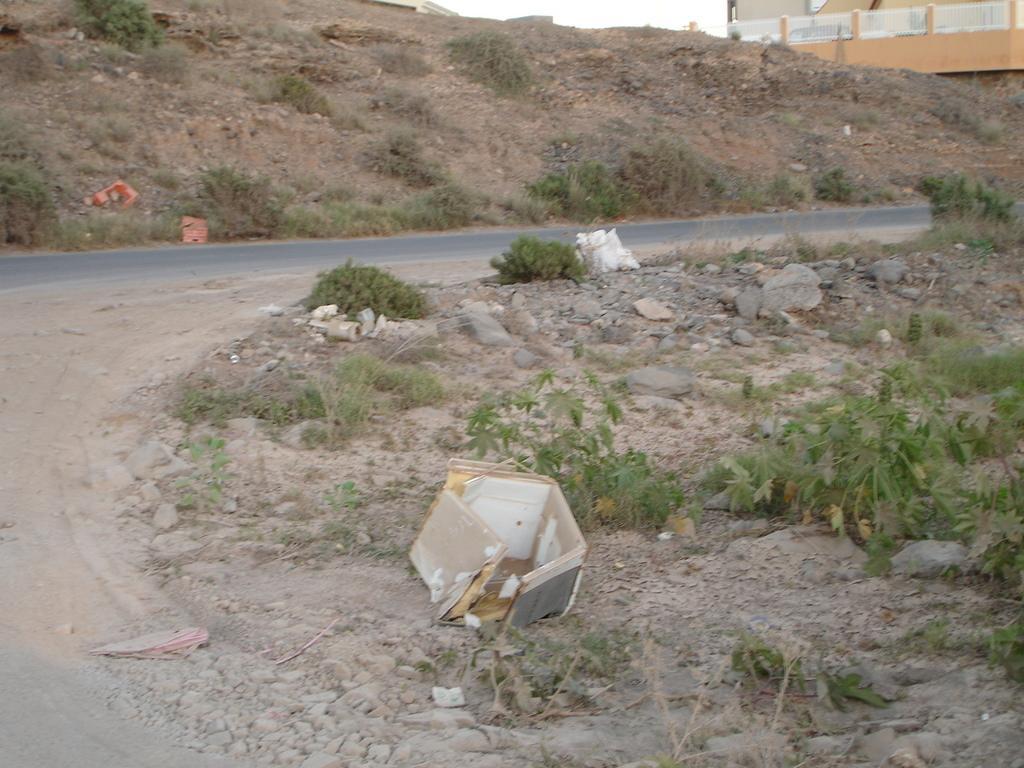Please provide a concise description of this image. In this image we can see a road. Also there are rocks. And there are plants. In the back there is a wall. 